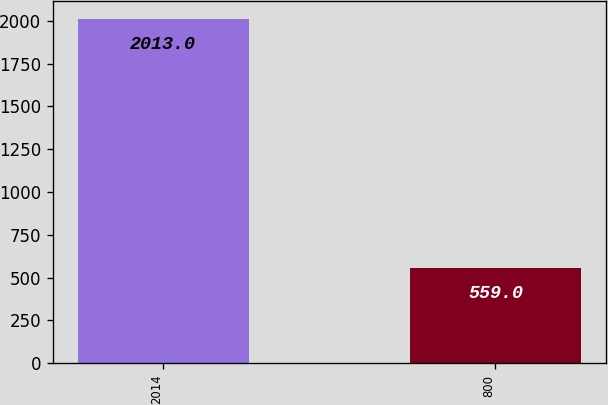Convert chart. <chart><loc_0><loc_0><loc_500><loc_500><bar_chart><fcel>2014<fcel>800<nl><fcel>2013<fcel>559<nl></chart> 